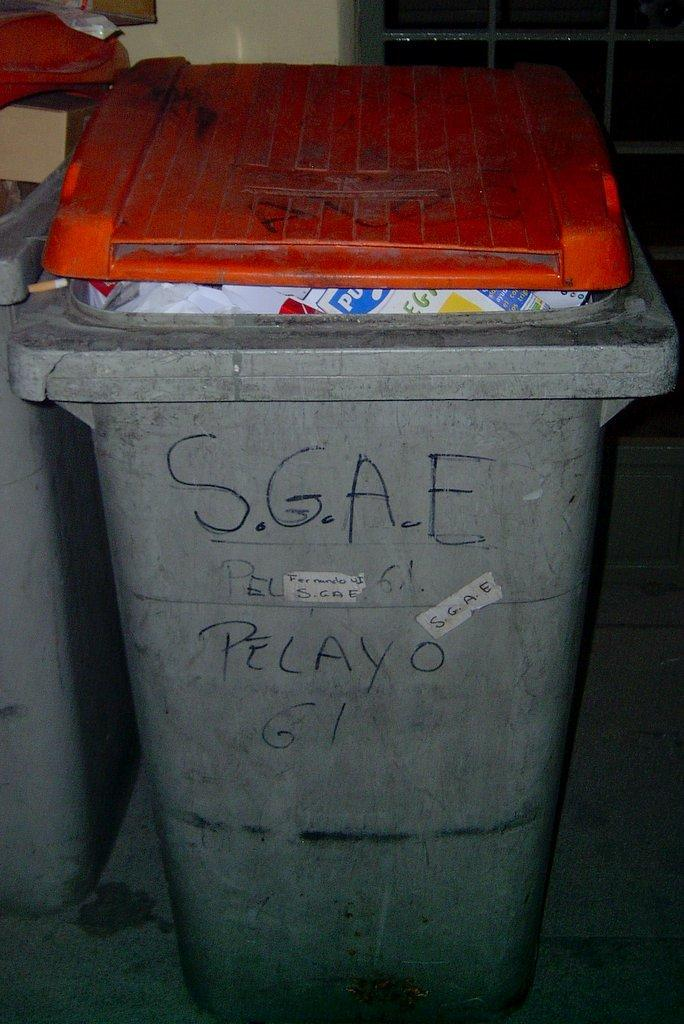<image>
Write a terse but informative summary of the picture. A grey container with an orange lid has black writing of S.G.A.E. 